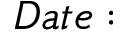<formula> <loc_0><loc_0><loc_500><loc_500>D a t e \colon</formula> 